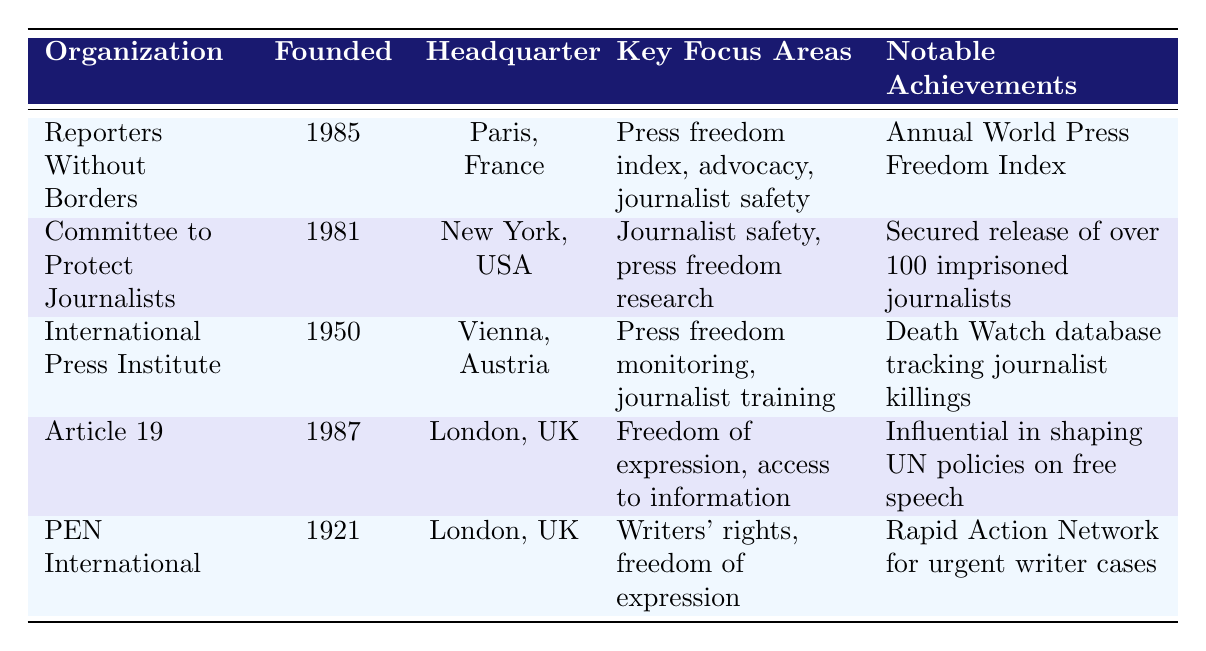What is the headquarters of Reporters Without Borders? The table lists the headquarters of each organization. For Reporters Without Borders, the headquarters is located in Paris, France.
Answer: Paris, France Which organization was founded first, Article 19 or PEN International? The founding years for Article 19 and PEN International are 1987 and 1921, respectively. Since 1921 is earlier than 1987, PEN International was founded first.
Answer: PEN International How many organizations listed focus on journalist safety? By checking the table, the organizations that focus on journalist safety are Reporters Without Borders and the Committee to Protect Journalists. There are 2 such organizations.
Answer: 2 Is the International Press Institute involved in monitoring press freedom? The table explicitly states that the International Press Institute's key focus areas include press freedom monitoring. Therefore, it is true that the organization is involved in this activity.
Answer: Yes Which organization has the notable achievement of influencing UN policies on free speech? Referring to the notable achievements column, Article 19 has shaped UN policies on free speech.
Answer: Article 19 What is the difference between the founding years of the Committee to Protect Journalists and Article 19? The Committee to Protect Journalists was founded in 1981 and Article 19 in 1987. The difference in their founding years is 1987 - 1981 = 6 years.
Answer: 6 years Which organization has its headquarters in the USA and is focused on press freedom research? The only organization listed that is headquartered in the USA and focuses on press freedom research is the Committee to Protect Journalists.
Answer: Committee to Protect Journalists Name an organization that tracks journalist killings. According to the table, the International Press Institute tracks journalist killings as part of its notable achievements.
Answer: International Press Institute Which two organizations are based in London? The table indicates that both Article 19 and PEN International are based in London, UK.
Answer: Article 19 and PEN International 